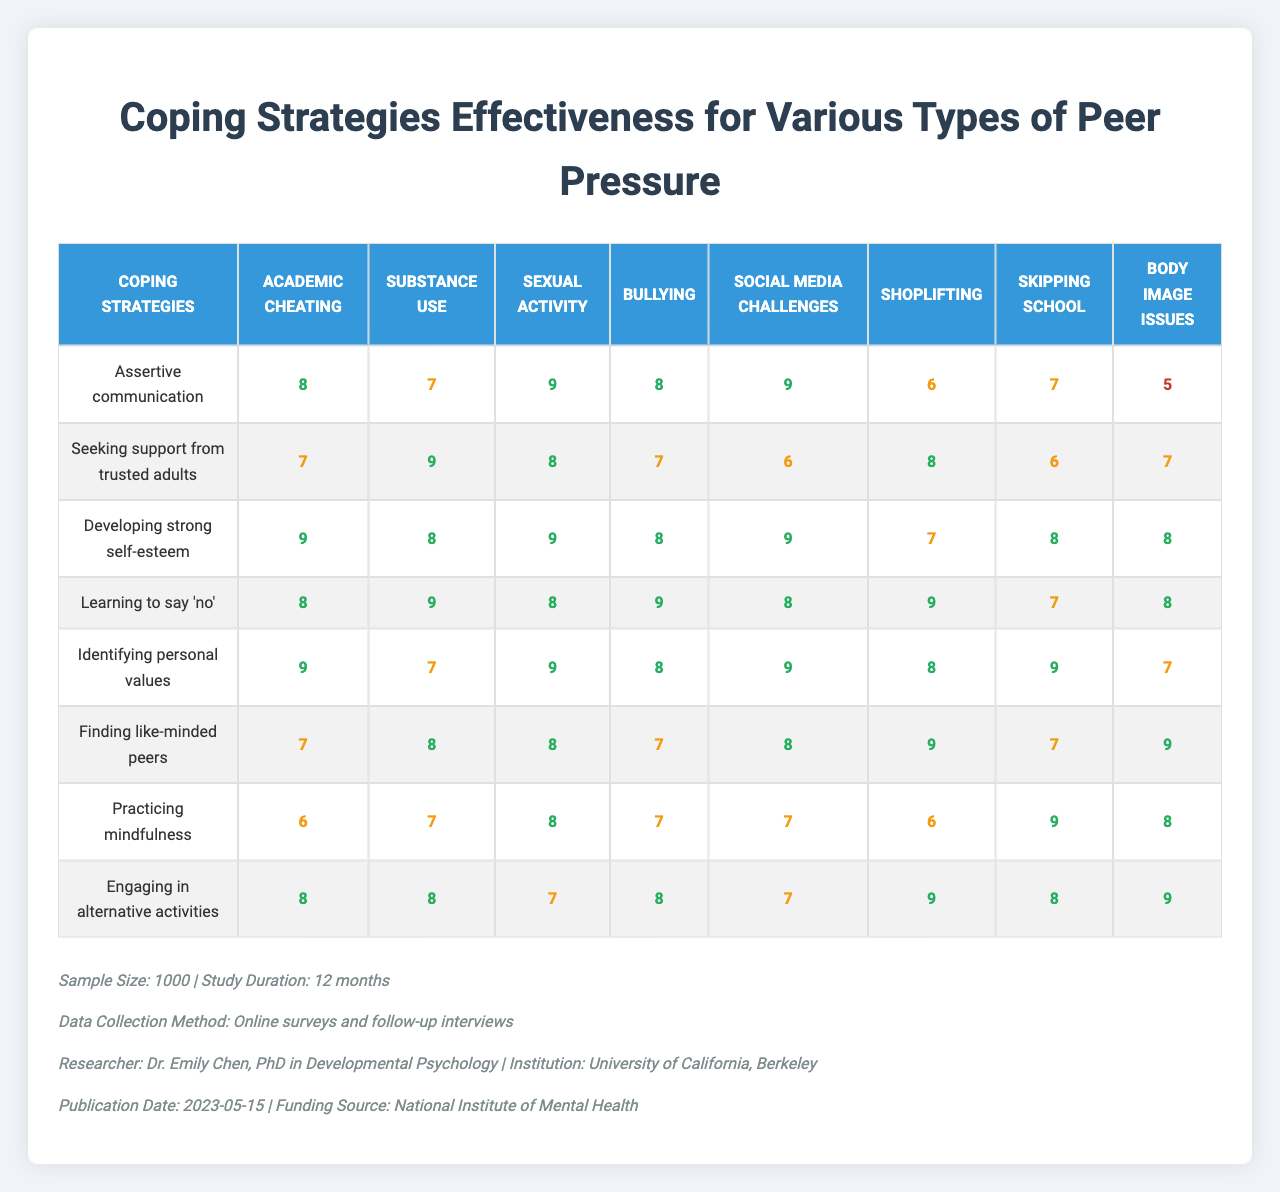What is the effectiveness score of "Assertive communication" for "Substance use"? The effectiveness score for "Assertive communication" under "Substance use" is found in the table. Looking at the specified row and column: it is 7.
Answer: 7 Which coping strategy has the highest score for "Academic cheating"? In the row for "Academic cheating", we look across all the coping strategies. The highest score appears to be 9 for "Developing strong self-esteem."
Answer: Developing strong self-esteem What is the average effectiveness score of "Practicing mindfulness" across all types of peer pressure? To find the average score, we add up all the scores for "Practicing mindfulness" (6 + 7 + 8 + 7 + 7 + 6 + 9 + 8) = 58. There are 8 scores, so we divide: 58 / 8 = 7.25.
Answer: 7.25 Is "Finding like-minded peers" more effective than "Learning to say 'no'" for "Shoplifting"? We check the scores for both coping strategies under "Shoplifting." "Finding like-minded peers" has a score of 9, while "Learning to say 'no'" has a score of 7. Since 9 is greater than 7, we conclude "Finding like-minded peers" is more effective.
Answer: Yes What coping strategy is most effective for "Sexual activity" based on the given scores? The effectiveness scores for "Sexual activity" are: 9, 8, 9, 9, 8, 8, 7, 8. The highest score of 9 appears for "Assertive communication," "Developing strong self-esteem," and "Learning to say 'no'." Therefore, multiple coping strategies have the same highest score for this type of peer pressure.
Answer: Assertive communication, Developing strong self-esteem, Learning to say 'no' What is the difference in effectiveness scores between "Engaging in alternative activities" and "Seeking support from trusted adults" for "Body image issues"? The scores for "Engaging in alternative activities" and "Seeking support from trusted adults" for "Body image issues" are 9 and 7, respectively. The difference can be calculated as 9 - 7 = 2.
Answer: 2 Which type of peer pressure shows the lowest average effectiveness score across all coping strategies? To find the type with the lowest average, we calculate the average for each peer pressure type. The scores for "Body image issues" (5 + 7 + 8 + 8 + 7 + 9 + 8 + 9 = 61) give an average of 7.625. This is the lowest score compared to the other types of peer pressure.
Answer: Body image issues How does the effectiveness of coping strategies vary for "Substance use" compared to "Skipping school"? For "Substance use," the scores are: 7, 9, 8, 9, 7, 8, 7, 8; averaging these gives a score of 8.625. For "Skipping school," the scores are: 8, 7, 8, 9, 9, 7, 9, 8; averaging these gives a score of 8.125. Since 8.625 > 8.125, coping strategies are overall more effective for "Substance use."
Answer: They are more effective for Substance use What percentage of coping strategies received a score of 9 for "Social media challenges"? Looking at the scores for "Social media challenges" (8, 7, 9, 8, 7, 8, 6, 8), only "Developing strong self-esteem" received a score of 9. With 1 out of 8 strategies scoring 9, the percentage is (1/8)*100 = 12.5%.
Answer: 12.5% What conclusion can be drawn about the effectiveness of "Practicing mindfulness" for various types of peer pressure? The scores for "Practicing mindfulness" are 6 for "Academic cheating," 7 for "Substance use," 8 for "Sexual activity," 7 for "Bullying," 7 for "Social media challenges," 6 for "Shoplifting," 9 for "Skipping school," and 8 for "Body image issues." The effectiveness varies, with scores from 6 to 9, indicating it’s moderately effective but not consistently high across all peer pressure types.
Answer: It varies in effectiveness, ranging from moderate to high scores 